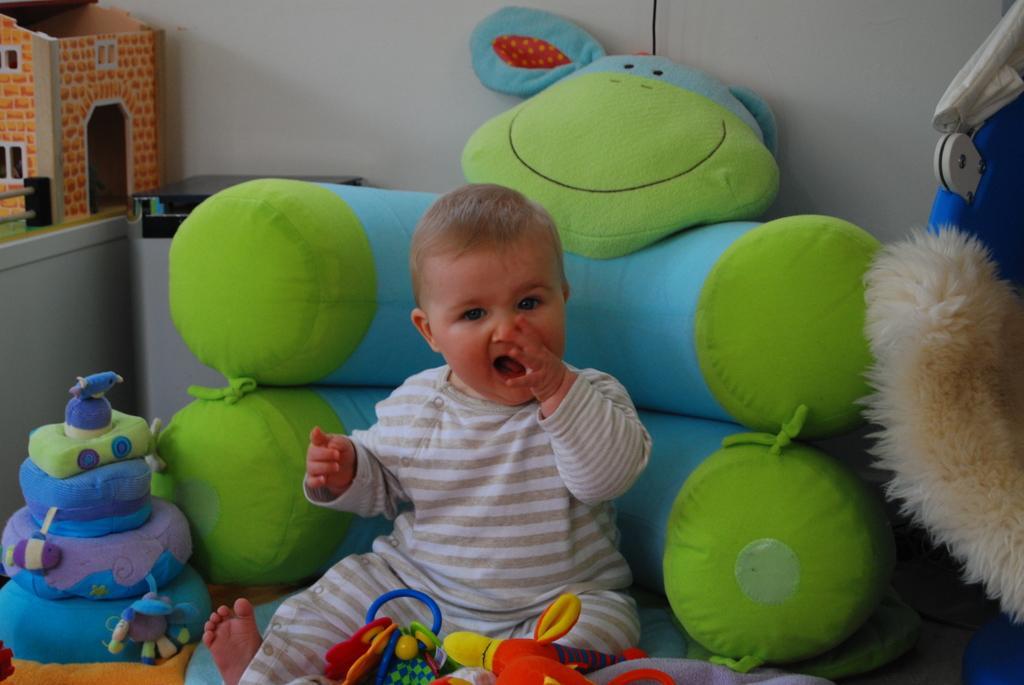Can you describe this image briefly? In this image there is a boy sitting in the sofa. There are toys around him. In the background there is a wall. On the left side there is a toy house on the desk. The kid is keeping his hand in his mouth. 